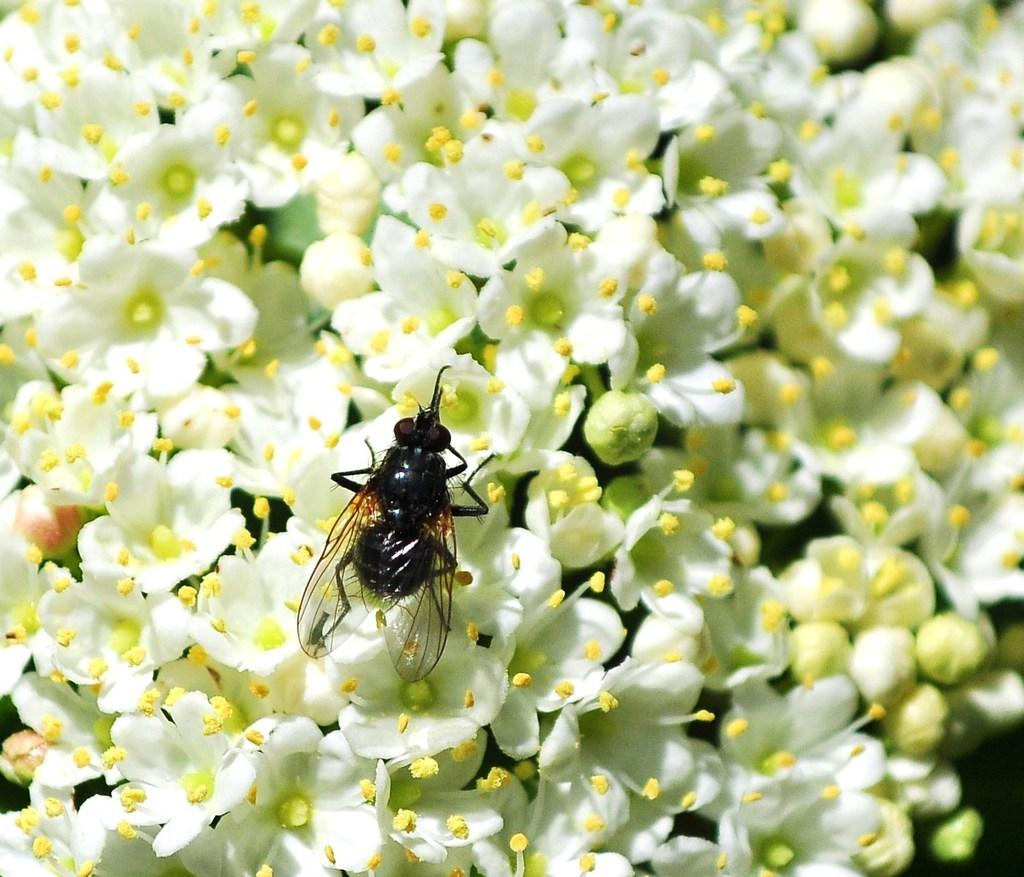What type of plants are in the image? There are flowers in the image. What color are the flowers? The flowers are white. Is there anything else present on the flowers? Yes, there is an insect on the flowers. What color is the insect? The insect is black. What type of drug is the insect carrying in the image? There is no drug present in the image, and the insect is not carrying anything. 